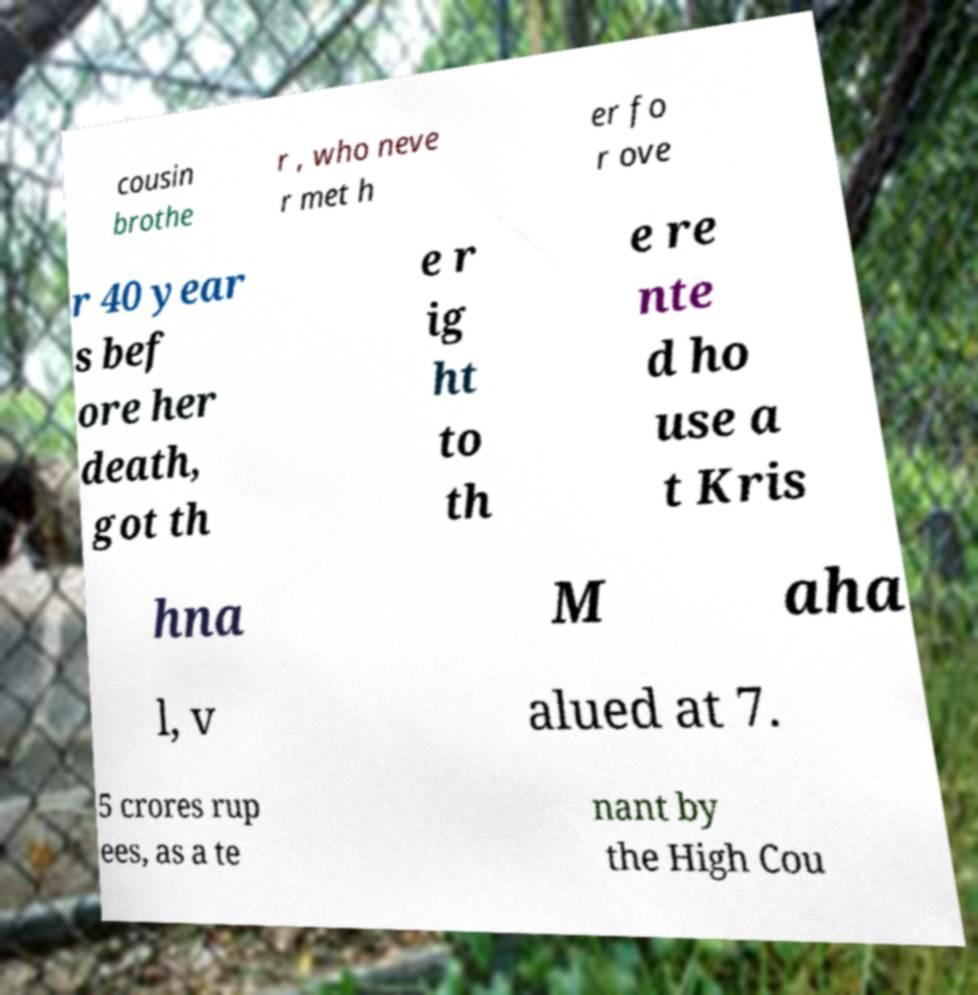Please identify and transcribe the text found in this image. cousin brothe r , who neve r met h er fo r ove r 40 year s bef ore her death, got th e r ig ht to th e re nte d ho use a t Kris hna M aha l, v alued at 7. 5 crores rup ees, as a te nant by the High Cou 